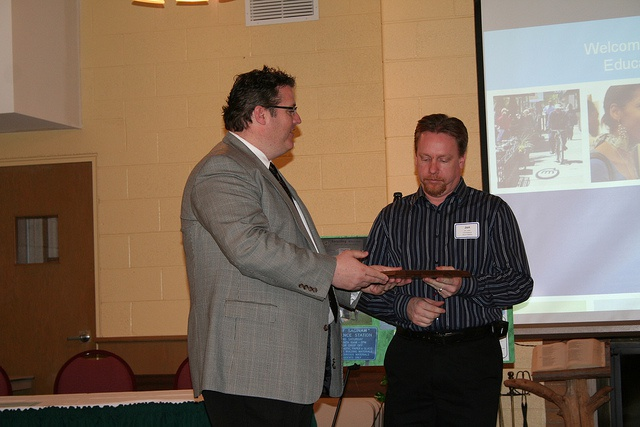Describe the objects in this image and their specific colors. I can see people in gray, black, brown, and tan tones, people in gray, black, brown, and maroon tones, dining table in gray, black, darkgray, and tan tones, chair in gray, maroon, brown, and olive tones, and book in gray and brown tones in this image. 